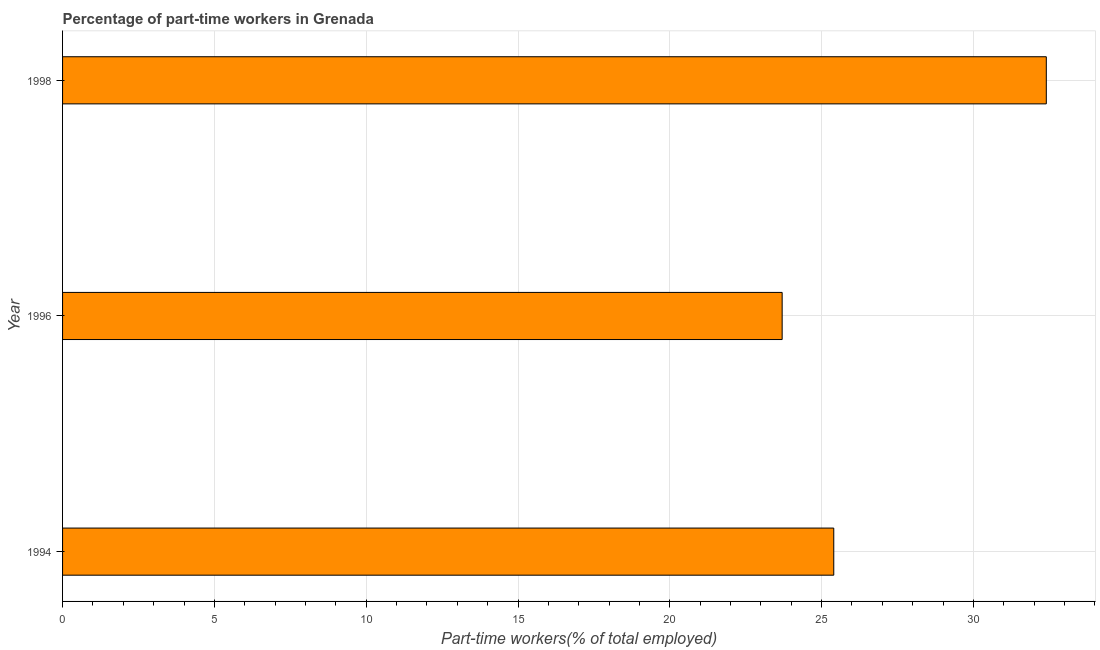Does the graph contain any zero values?
Make the answer very short. No. Does the graph contain grids?
Give a very brief answer. Yes. What is the title of the graph?
Provide a succinct answer. Percentage of part-time workers in Grenada. What is the label or title of the X-axis?
Your answer should be very brief. Part-time workers(% of total employed). What is the label or title of the Y-axis?
Keep it short and to the point. Year. What is the percentage of part-time workers in 1996?
Your response must be concise. 23.7. Across all years, what is the maximum percentage of part-time workers?
Offer a very short reply. 32.4. Across all years, what is the minimum percentage of part-time workers?
Your answer should be very brief. 23.7. In which year was the percentage of part-time workers maximum?
Provide a succinct answer. 1998. What is the sum of the percentage of part-time workers?
Keep it short and to the point. 81.5. What is the difference between the percentage of part-time workers in 1996 and 1998?
Keep it short and to the point. -8.7. What is the average percentage of part-time workers per year?
Provide a succinct answer. 27.17. What is the median percentage of part-time workers?
Provide a succinct answer. 25.4. Do a majority of the years between 1994 and 1996 (inclusive) have percentage of part-time workers greater than 28 %?
Offer a terse response. No. What is the ratio of the percentage of part-time workers in 1994 to that in 1996?
Offer a very short reply. 1.07. Is the difference between the percentage of part-time workers in 1996 and 1998 greater than the difference between any two years?
Your answer should be very brief. Yes. Is the sum of the percentage of part-time workers in 1996 and 1998 greater than the maximum percentage of part-time workers across all years?
Provide a succinct answer. Yes. What is the difference between the highest and the lowest percentage of part-time workers?
Your response must be concise. 8.7. In how many years, is the percentage of part-time workers greater than the average percentage of part-time workers taken over all years?
Provide a succinct answer. 1. How many bars are there?
Provide a short and direct response. 3. How many years are there in the graph?
Offer a very short reply. 3. What is the Part-time workers(% of total employed) in 1994?
Your answer should be compact. 25.4. What is the Part-time workers(% of total employed) of 1996?
Ensure brevity in your answer.  23.7. What is the Part-time workers(% of total employed) in 1998?
Offer a very short reply. 32.4. What is the difference between the Part-time workers(% of total employed) in 1994 and 1996?
Ensure brevity in your answer.  1.7. What is the difference between the Part-time workers(% of total employed) in 1994 and 1998?
Ensure brevity in your answer.  -7. What is the difference between the Part-time workers(% of total employed) in 1996 and 1998?
Your answer should be very brief. -8.7. What is the ratio of the Part-time workers(% of total employed) in 1994 to that in 1996?
Keep it short and to the point. 1.07. What is the ratio of the Part-time workers(% of total employed) in 1994 to that in 1998?
Your answer should be very brief. 0.78. What is the ratio of the Part-time workers(% of total employed) in 1996 to that in 1998?
Your answer should be very brief. 0.73. 